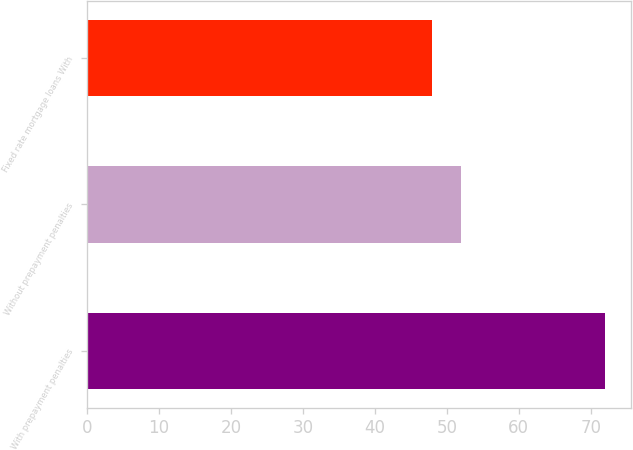Convert chart. <chart><loc_0><loc_0><loc_500><loc_500><bar_chart><fcel>With prepayment penalties<fcel>Without prepayment penalties<fcel>Fixed rate mortgage loans With<nl><fcel>72<fcel>52<fcel>48<nl></chart> 